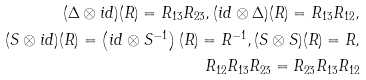Convert formula to latex. <formula><loc_0><loc_0><loc_500><loc_500>( \Delta \otimes i d ) ( R ) = R _ { 1 3 } R _ { 2 3 } , ( i d \otimes \Delta ) ( R ) = R _ { 1 3 } R _ { 1 2 } , \\ ( S \otimes i d ) ( R ) = \left ( i d \otimes S ^ { - 1 } \right ) ( R ) = R ^ { - 1 } , ( S \otimes S ) ( R ) = R , \\ R _ { 1 2 } R _ { 1 3 } R _ { 2 3 } = R _ { 2 3 } R _ { 1 3 } R _ { 1 2 }</formula> 